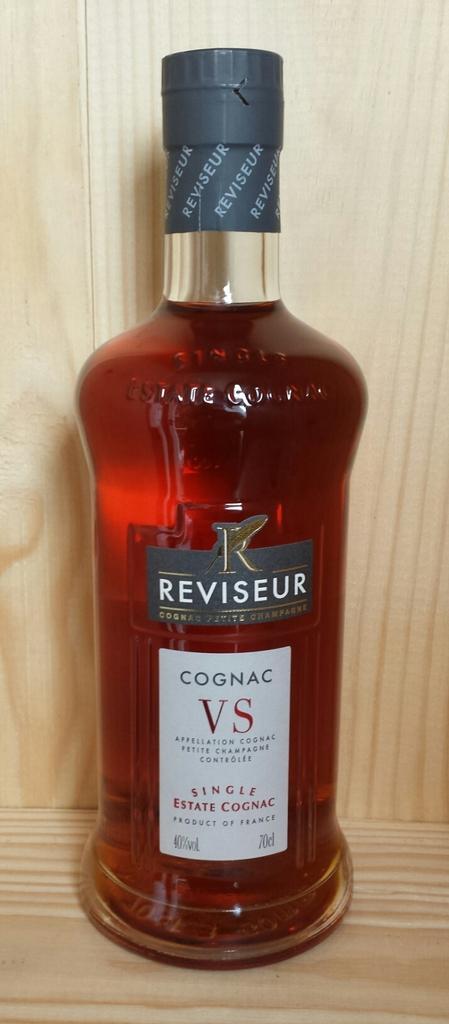Please provide a concise description of this image. This image consist of a wine bottle, kept in a rack. There is a sticker on the bottle on which it is written as ' Cognac VS'. 